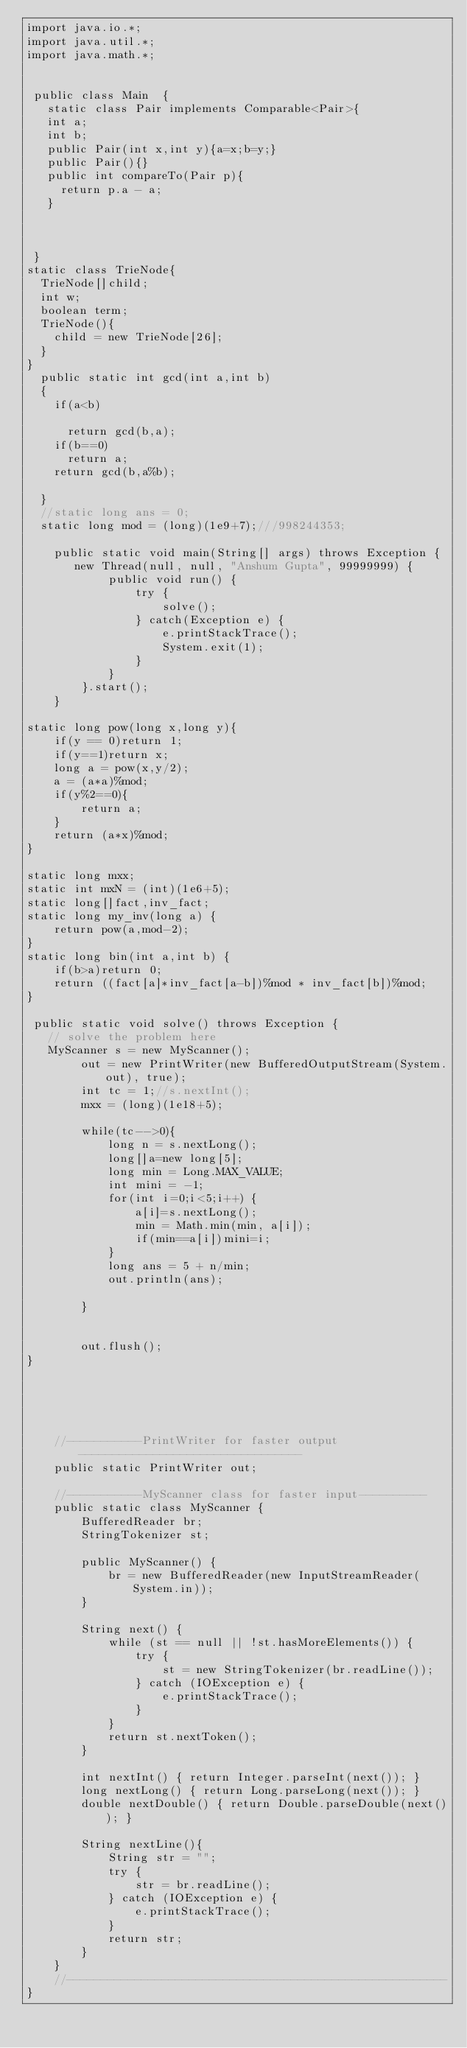<code> <loc_0><loc_0><loc_500><loc_500><_Java_>import java.io.*;
import java.util.*;
import java.math.*;

 
 public class Main	{
   static class Pair implements Comparable<Pair>{
   int a;
   int b;
   public Pair(int x,int y){a=x;b=y;}
   public Pair(){}
   public int compareTo(Pair p){
	 return p.a - a;
   }



 }
static class TrieNode{
  TrieNode[]child;
  int w;
  boolean term;
  TrieNode(){
    child = new TrieNode[26];  
  }
}
  public static int gcd(int a,int b)
  {
    if(a<b)

      return gcd(b,a);
    if(b==0)
      return a;
    return gcd(b,a%b);
    
  }
  //static long ans = 0;
  static long mod = (long)(1e9+7);///998244353;
   
    public static void main(String[] args) throws Exception {
       new Thread(null, null, "Anshum Gupta", 99999999) {
            public void run() {
                try {
                    solve();
                } catch(Exception e) {
                    e.printStackTrace();
                    System.exit(1);
                }
            }
        }.start();
    }

static long pow(long x,long y){
    if(y == 0)return 1;
    if(y==1)return x;
    long a = pow(x,y/2);
    a = (a*a)%mod;
    if(y%2==0){
        return a;
    }
    return (a*x)%mod;
}

static long mxx;
static int mxN = (int)(1e6+5);
static long[]fact,inv_fact;
static long my_inv(long a) {
	return pow(a,mod-2);
}
static long bin(int a,int b) {
	if(b>a)return 0;
    return ((fact[a]*inv_fact[a-b])%mod * inv_fact[b])%mod;
}

 public static void solve() throws Exception {
   // solve the problem here
   MyScanner s = new MyScanner();
        out = new PrintWriter(new BufferedOutputStream(System.out), true);
        int tc = 1;//s.nextInt();
        mxx = (long)(1e18+5);
       
        while(tc-->0){
        	long n = s.nextLong();
        	long[]a=new long[5];
        	long min = Long.MAX_VALUE;
        	int mini = -1;
        	for(int i=0;i<5;i++) {
        		a[i]=s.nextLong();
        		min = Math.min(min, a[i]);
        		if(min==a[i])mini=i;
        	}
        	long ans = 5 + n/min;
        	out.println(ans);
        	
        }
        
           
        out.flush();
}
 
     
 
 
 
    //-----------PrintWriter for faster output---------------------------------
    public static PrintWriter out;
 
    //-----------MyScanner class for faster input----------
    public static class MyScanner {
        BufferedReader br;
        StringTokenizer st;
 
        public MyScanner() {
            br = new BufferedReader(new InputStreamReader(System.in));
        }
 
        String next() {
            while (st == null || !st.hasMoreElements()) {
                try {
                    st = new StringTokenizer(br.readLine());
                } catch (IOException e) {
                    e.printStackTrace();
                }
            }
            return st.nextToken();
        }
 
        int nextInt() { return Integer.parseInt(next()); }
        long nextLong() { return Long.parseLong(next()); }
        double nextDouble() { return Double.parseDouble(next()); }
         
        String nextLine(){
            String str = "";
            try {
                str = br.readLine();
            } catch (IOException e) {
                e.printStackTrace();
            }
            return str;
        }
    }
    //--------------------------------------------------------
}
</code> 